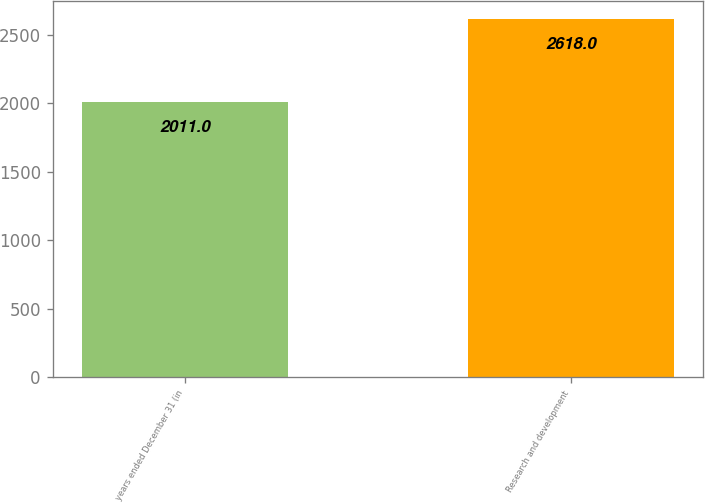Convert chart to OTSL. <chart><loc_0><loc_0><loc_500><loc_500><bar_chart><fcel>years ended December 31 (in<fcel>Research and development<nl><fcel>2011<fcel>2618<nl></chart> 